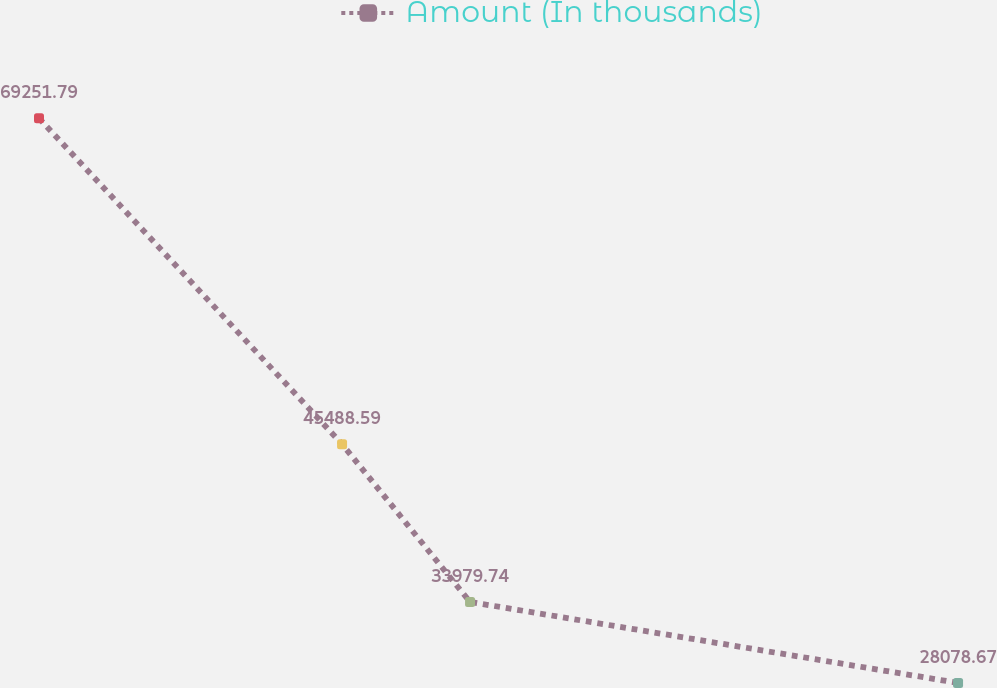Convert chart. <chart><loc_0><loc_0><loc_500><loc_500><line_chart><ecel><fcel>Amount (In thousands)<nl><fcel>1817.39<fcel>69251.8<nl><fcel>1939.9<fcel>45488.6<nl><fcel>1991.64<fcel>33979.7<nl><fcel>2188.91<fcel>28078.7<nl><fcel>2334.82<fcel>20890.9<nl></chart> 